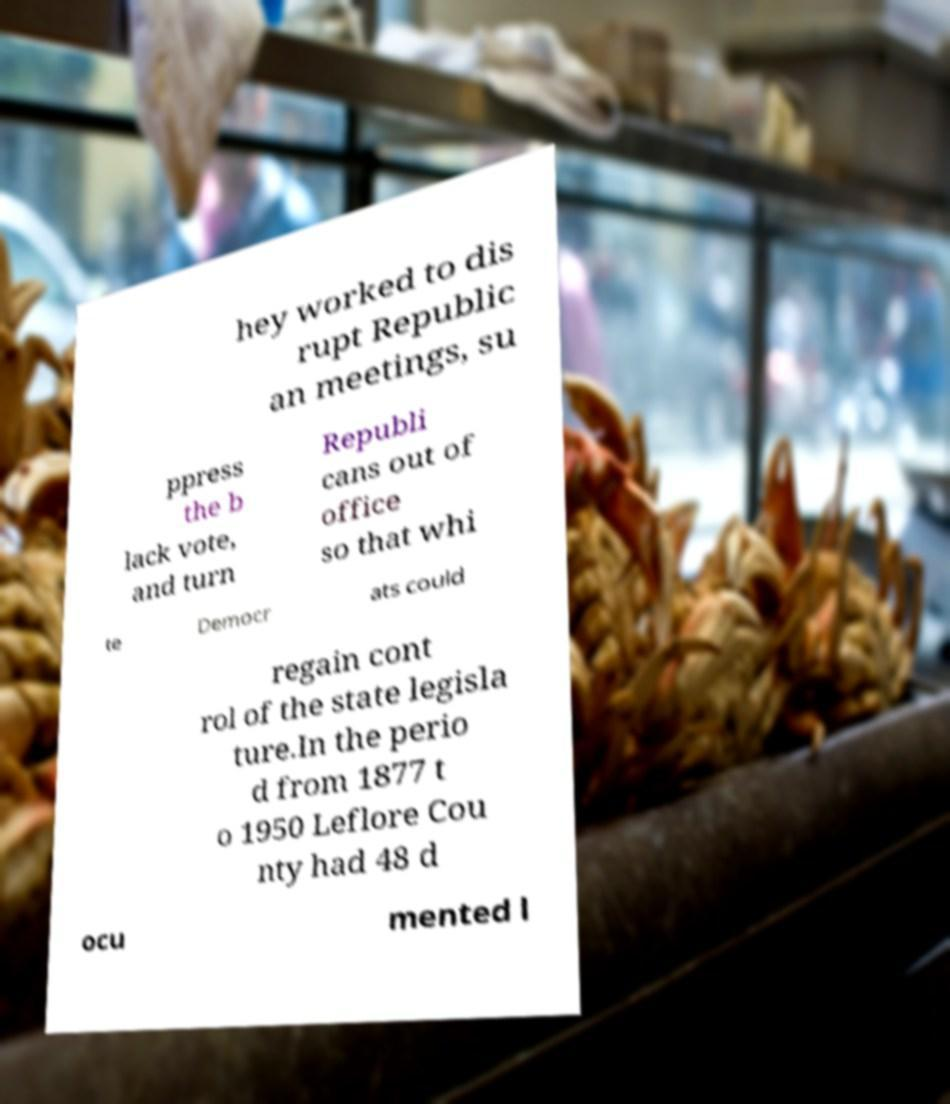For documentation purposes, I need the text within this image transcribed. Could you provide that? hey worked to dis rupt Republic an meetings, su ppress the b lack vote, and turn Republi cans out of office so that whi te Democr ats could regain cont rol of the state legisla ture.In the perio d from 1877 t o 1950 Leflore Cou nty had 48 d ocu mented l 